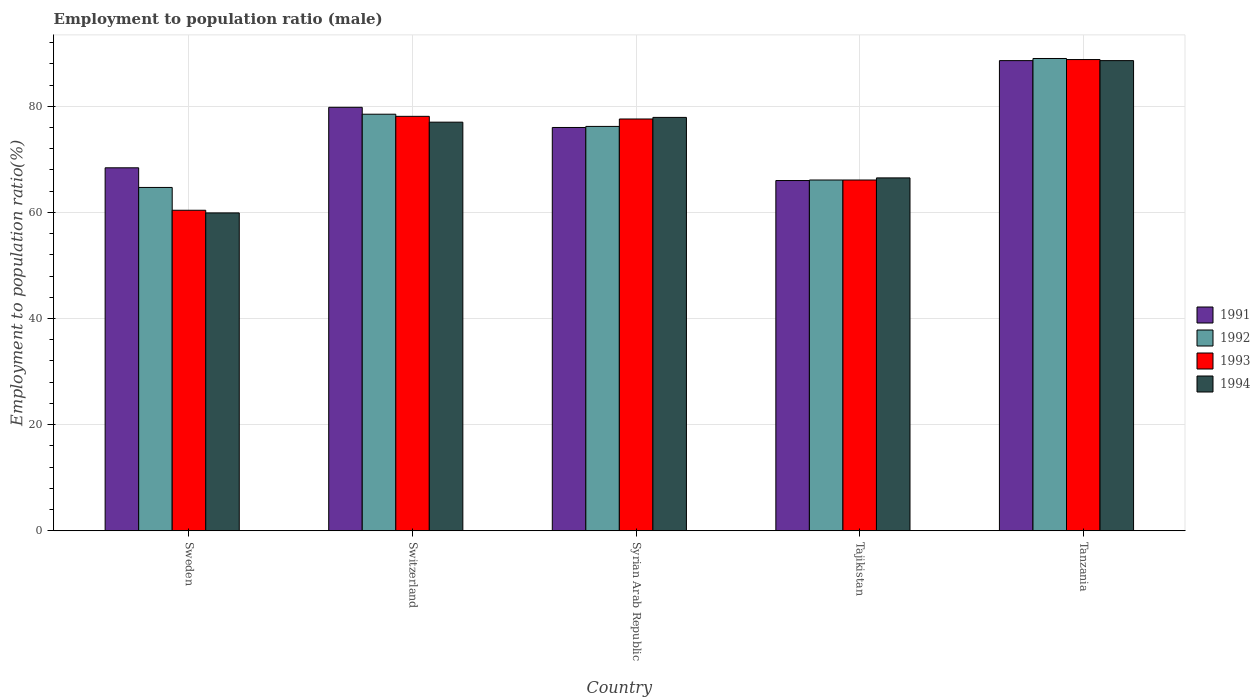How many different coloured bars are there?
Keep it short and to the point. 4. Are the number of bars per tick equal to the number of legend labels?
Offer a terse response. Yes. Are the number of bars on each tick of the X-axis equal?
Offer a very short reply. Yes. How many bars are there on the 3rd tick from the left?
Offer a very short reply. 4. How many bars are there on the 4th tick from the right?
Ensure brevity in your answer.  4. What is the label of the 4th group of bars from the left?
Offer a very short reply. Tajikistan. In how many cases, is the number of bars for a given country not equal to the number of legend labels?
Your answer should be compact. 0. What is the employment to population ratio in 1994 in Switzerland?
Provide a short and direct response. 77. Across all countries, what is the maximum employment to population ratio in 1994?
Offer a terse response. 88.6. In which country was the employment to population ratio in 1991 maximum?
Your answer should be very brief. Tanzania. What is the total employment to population ratio in 1992 in the graph?
Provide a short and direct response. 374.5. What is the difference between the employment to population ratio in 1994 in Switzerland and that in Tajikistan?
Offer a terse response. 10.5. What is the difference between the employment to population ratio in 1992 in Switzerland and the employment to population ratio in 1993 in Syrian Arab Republic?
Ensure brevity in your answer.  0.9. What is the average employment to population ratio in 1994 per country?
Your response must be concise. 73.98. What is the difference between the employment to population ratio of/in 1993 and employment to population ratio of/in 1994 in Tajikistan?
Give a very brief answer. -0.4. What is the ratio of the employment to population ratio in 1993 in Sweden to that in Tajikistan?
Your response must be concise. 0.91. Is the employment to population ratio in 1993 in Tajikistan less than that in Tanzania?
Give a very brief answer. Yes. Is the difference between the employment to population ratio in 1993 in Tajikistan and Tanzania greater than the difference between the employment to population ratio in 1994 in Tajikistan and Tanzania?
Keep it short and to the point. No. What is the difference between the highest and the second highest employment to population ratio in 1993?
Provide a short and direct response. 11.2. What is the difference between the highest and the lowest employment to population ratio in 1994?
Your response must be concise. 28.7. What does the 4th bar from the left in Switzerland represents?
Provide a succinct answer. 1994. What does the 4th bar from the right in Sweden represents?
Provide a succinct answer. 1991. Is it the case that in every country, the sum of the employment to population ratio in 1991 and employment to population ratio in 1993 is greater than the employment to population ratio in 1992?
Give a very brief answer. Yes. Are all the bars in the graph horizontal?
Offer a very short reply. No. How many countries are there in the graph?
Offer a terse response. 5. Does the graph contain grids?
Offer a very short reply. Yes. How are the legend labels stacked?
Provide a succinct answer. Vertical. What is the title of the graph?
Your answer should be compact. Employment to population ratio (male). Does "1977" appear as one of the legend labels in the graph?
Your answer should be compact. No. What is the label or title of the Y-axis?
Your answer should be very brief. Employment to population ratio(%). What is the Employment to population ratio(%) of 1991 in Sweden?
Your answer should be compact. 68.4. What is the Employment to population ratio(%) of 1992 in Sweden?
Ensure brevity in your answer.  64.7. What is the Employment to population ratio(%) in 1993 in Sweden?
Provide a short and direct response. 60.4. What is the Employment to population ratio(%) of 1994 in Sweden?
Your answer should be very brief. 59.9. What is the Employment to population ratio(%) in 1991 in Switzerland?
Offer a very short reply. 79.8. What is the Employment to population ratio(%) of 1992 in Switzerland?
Provide a succinct answer. 78.5. What is the Employment to population ratio(%) in 1993 in Switzerland?
Give a very brief answer. 78.1. What is the Employment to population ratio(%) of 1994 in Switzerland?
Provide a succinct answer. 77. What is the Employment to population ratio(%) of 1992 in Syrian Arab Republic?
Keep it short and to the point. 76.2. What is the Employment to population ratio(%) of 1993 in Syrian Arab Republic?
Provide a short and direct response. 77.6. What is the Employment to population ratio(%) in 1994 in Syrian Arab Republic?
Offer a terse response. 77.9. What is the Employment to population ratio(%) in 1992 in Tajikistan?
Keep it short and to the point. 66.1. What is the Employment to population ratio(%) of 1993 in Tajikistan?
Ensure brevity in your answer.  66.1. What is the Employment to population ratio(%) of 1994 in Tajikistan?
Your answer should be very brief. 66.5. What is the Employment to population ratio(%) of 1991 in Tanzania?
Your response must be concise. 88.6. What is the Employment to population ratio(%) in 1992 in Tanzania?
Your answer should be very brief. 89. What is the Employment to population ratio(%) in 1993 in Tanzania?
Provide a succinct answer. 88.8. What is the Employment to population ratio(%) of 1994 in Tanzania?
Provide a short and direct response. 88.6. Across all countries, what is the maximum Employment to population ratio(%) of 1991?
Offer a terse response. 88.6. Across all countries, what is the maximum Employment to population ratio(%) of 1992?
Offer a terse response. 89. Across all countries, what is the maximum Employment to population ratio(%) in 1993?
Your answer should be compact. 88.8. Across all countries, what is the maximum Employment to population ratio(%) in 1994?
Your answer should be compact. 88.6. Across all countries, what is the minimum Employment to population ratio(%) of 1991?
Offer a very short reply. 66. Across all countries, what is the minimum Employment to population ratio(%) in 1992?
Provide a short and direct response. 64.7. Across all countries, what is the minimum Employment to population ratio(%) in 1993?
Keep it short and to the point. 60.4. Across all countries, what is the minimum Employment to population ratio(%) of 1994?
Your answer should be very brief. 59.9. What is the total Employment to population ratio(%) in 1991 in the graph?
Ensure brevity in your answer.  378.8. What is the total Employment to population ratio(%) of 1992 in the graph?
Ensure brevity in your answer.  374.5. What is the total Employment to population ratio(%) of 1993 in the graph?
Your answer should be very brief. 371. What is the total Employment to population ratio(%) of 1994 in the graph?
Your response must be concise. 369.9. What is the difference between the Employment to population ratio(%) of 1991 in Sweden and that in Switzerland?
Give a very brief answer. -11.4. What is the difference between the Employment to population ratio(%) of 1993 in Sweden and that in Switzerland?
Provide a succinct answer. -17.7. What is the difference between the Employment to population ratio(%) in 1994 in Sweden and that in Switzerland?
Your response must be concise. -17.1. What is the difference between the Employment to population ratio(%) of 1993 in Sweden and that in Syrian Arab Republic?
Give a very brief answer. -17.2. What is the difference between the Employment to population ratio(%) of 1994 in Sweden and that in Syrian Arab Republic?
Keep it short and to the point. -18. What is the difference between the Employment to population ratio(%) of 1991 in Sweden and that in Tajikistan?
Make the answer very short. 2.4. What is the difference between the Employment to population ratio(%) in 1993 in Sweden and that in Tajikistan?
Provide a succinct answer. -5.7. What is the difference between the Employment to population ratio(%) of 1994 in Sweden and that in Tajikistan?
Offer a terse response. -6.6. What is the difference between the Employment to population ratio(%) of 1991 in Sweden and that in Tanzania?
Your response must be concise. -20.2. What is the difference between the Employment to population ratio(%) in 1992 in Sweden and that in Tanzania?
Provide a succinct answer. -24.3. What is the difference between the Employment to population ratio(%) of 1993 in Sweden and that in Tanzania?
Offer a very short reply. -28.4. What is the difference between the Employment to population ratio(%) in 1994 in Sweden and that in Tanzania?
Provide a short and direct response. -28.7. What is the difference between the Employment to population ratio(%) of 1992 in Switzerland and that in Syrian Arab Republic?
Offer a very short reply. 2.3. What is the difference between the Employment to population ratio(%) in 1993 in Switzerland and that in Syrian Arab Republic?
Ensure brevity in your answer.  0.5. What is the difference between the Employment to population ratio(%) of 1993 in Switzerland and that in Tajikistan?
Your response must be concise. 12. What is the difference between the Employment to population ratio(%) in 1994 in Switzerland and that in Tajikistan?
Your answer should be compact. 10.5. What is the difference between the Employment to population ratio(%) of 1991 in Switzerland and that in Tanzania?
Offer a terse response. -8.8. What is the difference between the Employment to population ratio(%) in 1992 in Switzerland and that in Tanzania?
Ensure brevity in your answer.  -10.5. What is the difference between the Employment to population ratio(%) in 1993 in Syrian Arab Republic and that in Tajikistan?
Provide a short and direct response. 11.5. What is the difference between the Employment to population ratio(%) in 1992 in Syrian Arab Republic and that in Tanzania?
Offer a terse response. -12.8. What is the difference between the Employment to population ratio(%) in 1991 in Tajikistan and that in Tanzania?
Offer a terse response. -22.6. What is the difference between the Employment to population ratio(%) of 1992 in Tajikistan and that in Tanzania?
Your answer should be compact. -22.9. What is the difference between the Employment to population ratio(%) in 1993 in Tajikistan and that in Tanzania?
Provide a succinct answer. -22.7. What is the difference between the Employment to population ratio(%) of 1994 in Tajikistan and that in Tanzania?
Provide a succinct answer. -22.1. What is the difference between the Employment to population ratio(%) in 1991 in Sweden and the Employment to population ratio(%) in 1992 in Switzerland?
Offer a terse response. -10.1. What is the difference between the Employment to population ratio(%) in 1991 in Sweden and the Employment to population ratio(%) in 1993 in Switzerland?
Offer a terse response. -9.7. What is the difference between the Employment to population ratio(%) of 1991 in Sweden and the Employment to population ratio(%) of 1994 in Switzerland?
Provide a short and direct response. -8.6. What is the difference between the Employment to population ratio(%) of 1992 in Sweden and the Employment to population ratio(%) of 1993 in Switzerland?
Make the answer very short. -13.4. What is the difference between the Employment to population ratio(%) in 1993 in Sweden and the Employment to population ratio(%) in 1994 in Switzerland?
Your response must be concise. -16.6. What is the difference between the Employment to population ratio(%) of 1992 in Sweden and the Employment to population ratio(%) of 1994 in Syrian Arab Republic?
Offer a very short reply. -13.2. What is the difference between the Employment to population ratio(%) in 1993 in Sweden and the Employment to population ratio(%) in 1994 in Syrian Arab Republic?
Your answer should be compact. -17.5. What is the difference between the Employment to population ratio(%) of 1991 in Sweden and the Employment to population ratio(%) of 1992 in Tajikistan?
Ensure brevity in your answer.  2.3. What is the difference between the Employment to population ratio(%) of 1991 in Sweden and the Employment to population ratio(%) of 1993 in Tajikistan?
Offer a terse response. 2.3. What is the difference between the Employment to population ratio(%) of 1992 in Sweden and the Employment to population ratio(%) of 1993 in Tajikistan?
Provide a succinct answer. -1.4. What is the difference between the Employment to population ratio(%) in 1991 in Sweden and the Employment to population ratio(%) in 1992 in Tanzania?
Offer a very short reply. -20.6. What is the difference between the Employment to population ratio(%) of 1991 in Sweden and the Employment to population ratio(%) of 1993 in Tanzania?
Provide a succinct answer. -20.4. What is the difference between the Employment to population ratio(%) in 1991 in Sweden and the Employment to population ratio(%) in 1994 in Tanzania?
Make the answer very short. -20.2. What is the difference between the Employment to population ratio(%) of 1992 in Sweden and the Employment to population ratio(%) of 1993 in Tanzania?
Keep it short and to the point. -24.1. What is the difference between the Employment to population ratio(%) in 1992 in Sweden and the Employment to population ratio(%) in 1994 in Tanzania?
Ensure brevity in your answer.  -23.9. What is the difference between the Employment to population ratio(%) of 1993 in Sweden and the Employment to population ratio(%) of 1994 in Tanzania?
Give a very brief answer. -28.2. What is the difference between the Employment to population ratio(%) of 1991 in Switzerland and the Employment to population ratio(%) of 1992 in Syrian Arab Republic?
Your response must be concise. 3.6. What is the difference between the Employment to population ratio(%) of 1991 in Switzerland and the Employment to population ratio(%) of 1993 in Syrian Arab Republic?
Your answer should be compact. 2.2. What is the difference between the Employment to population ratio(%) in 1991 in Switzerland and the Employment to population ratio(%) in 1994 in Syrian Arab Republic?
Ensure brevity in your answer.  1.9. What is the difference between the Employment to population ratio(%) of 1992 in Switzerland and the Employment to population ratio(%) of 1993 in Syrian Arab Republic?
Offer a terse response. 0.9. What is the difference between the Employment to population ratio(%) in 1993 in Switzerland and the Employment to population ratio(%) in 1994 in Syrian Arab Republic?
Your answer should be compact. 0.2. What is the difference between the Employment to population ratio(%) in 1991 in Switzerland and the Employment to population ratio(%) in 1994 in Tajikistan?
Make the answer very short. 13.3. What is the difference between the Employment to population ratio(%) in 1992 in Switzerland and the Employment to population ratio(%) in 1994 in Tajikistan?
Offer a very short reply. 12. What is the difference between the Employment to population ratio(%) in 1991 in Switzerland and the Employment to population ratio(%) in 1994 in Tanzania?
Offer a terse response. -8.8. What is the difference between the Employment to population ratio(%) in 1992 in Switzerland and the Employment to population ratio(%) in 1994 in Tanzania?
Offer a very short reply. -10.1. What is the difference between the Employment to population ratio(%) of 1991 in Syrian Arab Republic and the Employment to population ratio(%) of 1992 in Tajikistan?
Ensure brevity in your answer.  9.9. What is the difference between the Employment to population ratio(%) of 1991 in Syrian Arab Republic and the Employment to population ratio(%) of 1994 in Tajikistan?
Your answer should be very brief. 9.5. What is the difference between the Employment to population ratio(%) of 1993 in Syrian Arab Republic and the Employment to population ratio(%) of 1994 in Tajikistan?
Your response must be concise. 11.1. What is the difference between the Employment to population ratio(%) of 1991 in Syrian Arab Republic and the Employment to population ratio(%) of 1992 in Tanzania?
Keep it short and to the point. -13. What is the difference between the Employment to population ratio(%) of 1991 in Syrian Arab Republic and the Employment to population ratio(%) of 1994 in Tanzania?
Give a very brief answer. -12.6. What is the difference between the Employment to population ratio(%) of 1992 in Syrian Arab Republic and the Employment to population ratio(%) of 1994 in Tanzania?
Your answer should be compact. -12.4. What is the difference between the Employment to population ratio(%) of 1993 in Syrian Arab Republic and the Employment to population ratio(%) of 1994 in Tanzania?
Offer a terse response. -11. What is the difference between the Employment to population ratio(%) in 1991 in Tajikistan and the Employment to population ratio(%) in 1992 in Tanzania?
Make the answer very short. -23. What is the difference between the Employment to population ratio(%) of 1991 in Tajikistan and the Employment to population ratio(%) of 1993 in Tanzania?
Ensure brevity in your answer.  -22.8. What is the difference between the Employment to population ratio(%) in 1991 in Tajikistan and the Employment to population ratio(%) in 1994 in Tanzania?
Your response must be concise. -22.6. What is the difference between the Employment to population ratio(%) of 1992 in Tajikistan and the Employment to population ratio(%) of 1993 in Tanzania?
Make the answer very short. -22.7. What is the difference between the Employment to population ratio(%) in 1992 in Tajikistan and the Employment to population ratio(%) in 1994 in Tanzania?
Make the answer very short. -22.5. What is the difference between the Employment to population ratio(%) in 1993 in Tajikistan and the Employment to population ratio(%) in 1994 in Tanzania?
Give a very brief answer. -22.5. What is the average Employment to population ratio(%) of 1991 per country?
Offer a terse response. 75.76. What is the average Employment to population ratio(%) of 1992 per country?
Keep it short and to the point. 74.9. What is the average Employment to population ratio(%) of 1993 per country?
Your response must be concise. 74.2. What is the average Employment to population ratio(%) of 1994 per country?
Your answer should be very brief. 73.98. What is the difference between the Employment to population ratio(%) in 1991 and Employment to population ratio(%) in 1992 in Sweden?
Keep it short and to the point. 3.7. What is the difference between the Employment to population ratio(%) in 1992 and Employment to population ratio(%) in 1993 in Sweden?
Your answer should be very brief. 4.3. What is the difference between the Employment to population ratio(%) of 1992 and Employment to population ratio(%) of 1994 in Sweden?
Your response must be concise. 4.8. What is the difference between the Employment to population ratio(%) in 1993 and Employment to population ratio(%) in 1994 in Switzerland?
Offer a very short reply. 1.1. What is the difference between the Employment to population ratio(%) of 1991 and Employment to population ratio(%) of 1992 in Syrian Arab Republic?
Your answer should be compact. -0.2. What is the difference between the Employment to population ratio(%) of 1991 and Employment to population ratio(%) of 1993 in Syrian Arab Republic?
Your answer should be compact. -1.6. What is the difference between the Employment to population ratio(%) in 1992 and Employment to population ratio(%) in 1993 in Tajikistan?
Offer a very short reply. 0. What is the difference between the Employment to population ratio(%) of 1992 and Employment to population ratio(%) of 1993 in Tanzania?
Offer a very short reply. 0.2. What is the difference between the Employment to population ratio(%) of 1993 and Employment to population ratio(%) of 1994 in Tanzania?
Make the answer very short. 0.2. What is the ratio of the Employment to population ratio(%) of 1992 in Sweden to that in Switzerland?
Your answer should be very brief. 0.82. What is the ratio of the Employment to population ratio(%) in 1993 in Sweden to that in Switzerland?
Offer a terse response. 0.77. What is the ratio of the Employment to population ratio(%) of 1994 in Sweden to that in Switzerland?
Your answer should be very brief. 0.78. What is the ratio of the Employment to population ratio(%) in 1992 in Sweden to that in Syrian Arab Republic?
Provide a succinct answer. 0.85. What is the ratio of the Employment to population ratio(%) of 1993 in Sweden to that in Syrian Arab Republic?
Ensure brevity in your answer.  0.78. What is the ratio of the Employment to population ratio(%) of 1994 in Sweden to that in Syrian Arab Republic?
Offer a terse response. 0.77. What is the ratio of the Employment to population ratio(%) in 1991 in Sweden to that in Tajikistan?
Your answer should be compact. 1.04. What is the ratio of the Employment to population ratio(%) of 1992 in Sweden to that in Tajikistan?
Keep it short and to the point. 0.98. What is the ratio of the Employment to population ratio(%) in 1993 in Sweden to that in Tajikistan?
Make the answer very short. 0.91. What is the ratio of the Employment to population ratio(%) of 1994 in Sweden to that in Tajikistan?
Make the answer very short. 0.9. What is the ratio of the Employment to population ratio(%) of 1991 in Sweden to that in Tanzania?
Your answer should be very brief. 0.77. What is the ratio of the Employment to population ratio(%) in 1992 in Sweden to that in Tanzania?
Offer a terse response. 0.73. What is the ratio of the Employment to population ratio(%) in 1993 in Sweden to that in Tanzania?
Your response must be concise. 0.68. What is the ratio of the Employment to population ratio(%) in 1994 in Sweden to that in Tanzania?
Ensure brevity in your answer.  0.68. What is the ratio of the Employment to population ratio(%) of 1992 in Switzerland to that in Syrian Arab Republic?
Offer a very short reply. 1.03. What is the ratio of the Employment to population ratio(%) in 1993 in Switzerland to that in Syrian Arab Republic?
Make the answer very short. 1.01. What is the ratio of the Employment to population ratio(%) in 1994 in Switzerland to that in Syrian Arab Republic?
Give a very brief answer. 0.99. What is the ratio of the Employment to population ratio(%) of 1991 in Switzerland to that in Tajikistan?
Your answer should be compact. 1.21. What is the ratio of the Employment to population ratio(%) of 1992 in Switzerland to that in Tajikistan?
Ensure brevity in your answer.  1.19. What is the ratio of the Employment to population ratio(%) of 1993 in Switzerland to that in Tajikistan?
Your answer should be compact. 1.18. What is the ratio of the Employment to population ratio(%) of 1994 in Switzerland to that in Tajikistan?
Offer a very short reply. 1.16. What is the ratio of the Employment to population ratio(%) in 1991 in Switzerland to that in Tanzania?
Ensure brevity in your answer.  0.9. What is the ratio of the Employment to population ratio(%) of 1992 in Switzerland to that in Tanzania?
Your answer should be very brief. 0.88. What is the ratio of the Employment to population ratio(%) of 1993 in Switzerland to that in Tanzania?
Make the answer very short. 0.88. What is the ratio of the Employment to population ratio(%) in 1994 in Switzerland to that in Tanzania?
Your answer should be very brief. 0.87. What is the ratio of the Employment to population ratio(%) in 1991 in Syrian Arab Republic to that in Tajikistan?
Your response must be concise. 1.15. What is the ratio of the Employment to population ratio(%) in 1992 in Syrian Arab Republic to that in Tajikistan?
Ensure brevity in your answer.  1.15. What is the ratio of the Employment to population ratio(%) in 1993 in Syrian Arab Republic to that in Tajikistan?
Your answer should be very brief. 1.17. What is the ratio of the Employment to population ratio(%) of 1994 in Syrian Arab Republic to that in Tajikistan?
Your response must be concise. 1.17. What is the ratio of the Employment to population ratio(%) in 1991 in Syrian Arab Republic to that in Tanzania?
Provide a short and direct response. 0.86. What is the ratio of the Employment to population ratio(%) in 1992 in Syrian Arab Republic to that in Tanzania?
Offer a very short reply. 0.86. What is the ratio of the Employment to population ratio(%) in 1993 in Syrian Arab Republic to that in Tanzania?
Your response must be concise. 0.87. What is the ratio of the Employment to population ratio(%) in 1994 in Syrian Arab Republic to that in Tanzania?
Provide a succinct answer. 0.88. What is the ratio of the Employment to population ratio(%) in 1991 in Tajikistan to that in Tanzania?
Your response must be concise. 0.74. What is the ratio of the Employment to population ratio(%) of 1992 in Tajikistan to that in Tanzania?
Make the answer very short. 0.74. What is the ratio of the Employment to population ratio(%) of 1993 in Tajikistan to that in Tanzania?
Ensure brevity in your answer.  0.74. What is the ratio of the Employment to population ratio(%) of 1994 in Tajikistan to that in Tanzania?
Provide a succinct answer. 0.75. What is the difference between the highest and the second highest Employment to population ratio(%) of 1991?
Your answer should be compact. 8.8. What is the difference between the highest and the second highest Employment to population ratio(%) of 1992?
Keep it short and to the point. 10.5. What is the difference between the highest and the lowest Employment to population ratio(%) in 1991?
Your answer should be compact. 22.6. What is the difference between the highest and the lowest Employment to population ratio(%) in 1992?
Offer a very short reply. 24.3. What is the difference between the highest and the lowest Employment to population ratio(%) of 1993?
Your answer should be compact. 28.4. What is the difference between the highest and the lowest Employment to population ratio(%) of 1994?
Your answer should be very brief. 28.7. 